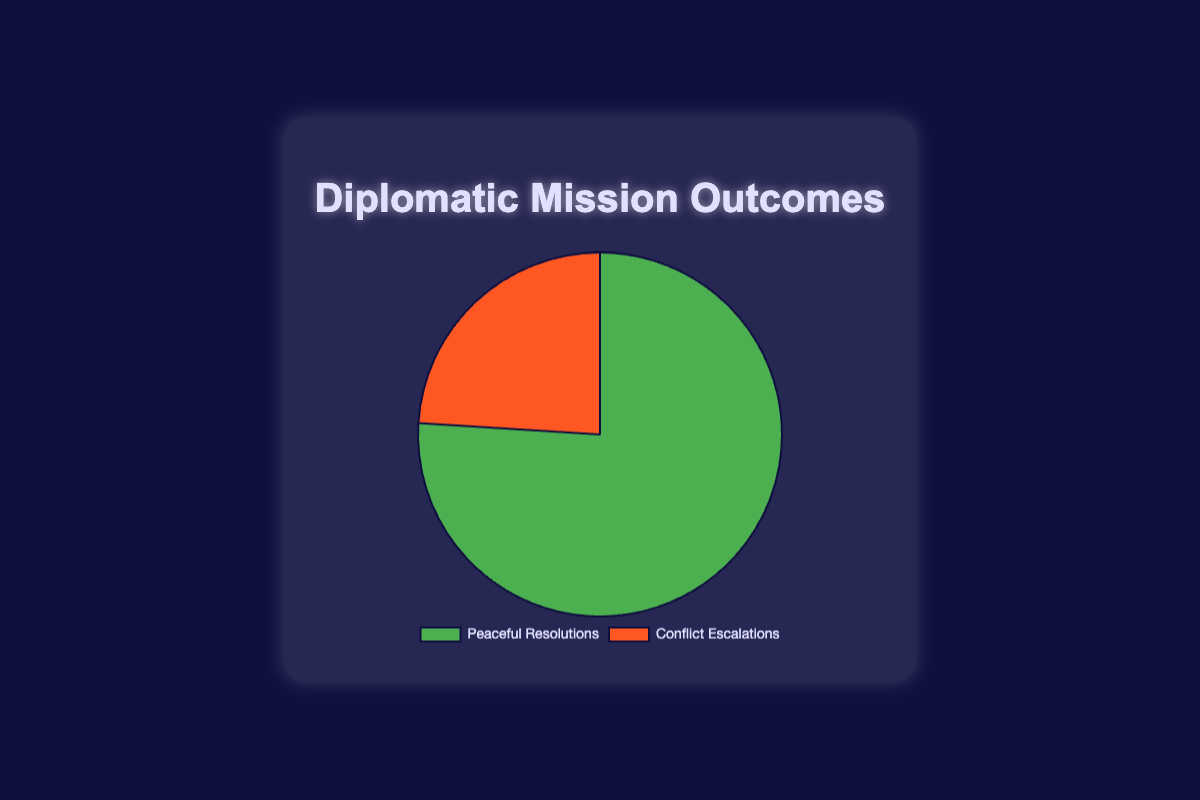What percentage of the outcomes resulted in Peaceful Resolutions? The pie chart indicates the percentage of outcomes. The section labeled "Peaceful Resolutions" shows 76%.
Answer: 76% How does the number of Conflict Escalations compare to Peaceful Resolutions? By comparing the sections of the pie chart, Peaceful Resolutions have a larger percentage (76%) compared to Conflict Escalations (24%).
Answer: Peaceful Resolutions > Conflict Escalations What is the difference between the percentage of Peaceful Resolutions and Conflict Escalations? The percentage for Peaceful Resolutions is 76%, and for Conflict Escalations is 24%. The difference is 76% - 24% = 52%.
Answer: 52% What fraction of the outcomes were Conflict Escalations? The chart shows that 24% of the outcomes were Conflict Escalations. To convert this percentage to a fraction, 24/100 can be simplified to 6/25.
Answer: 6/25 If there were 100 diplomatic missions, how many resulted in Peaceful Resolutions? Given 76% were Peaceful Resolutions, for 100 missions, 76% of 100 = 76 missions.
Answer: 76 If the data were to represent 1,000 diplomatic missions, how many would result in Conflict Escalations? For Conflict Escalations, 24% out of 1,000 missions is calculated by (24/100) * 1,000 = 240 missions.
Answer: 240 What is the combined percentage of missions that did not result in Conflict Escalations? Missions that did not result in Conflict Escalations are Peaceful Resolutions, which are 76%.
Answer: 76% Which outcome is represented by the green section of the pie chart? By looking at the color coding, the green section corresponds to the label "Peaceful Resolutions."
Answer: Peaceful Resolutions By how many times is the percentage of Peaceful Resolutions greater than Conflict Escalations? Peaceful Resolutions are 76%, and Conflict Escalations are 24%. To find how many times larger, 76/24 ≈ 3.17 times larger.
Answer: Approximately 3.17 times Calculate the total sum of percentages in the pie chart. The sum of the percentages of Peaceful Resolutions (76%) and Conflict Escalations (24%) is 76% + 24% = 100%.
Answer: 100% 